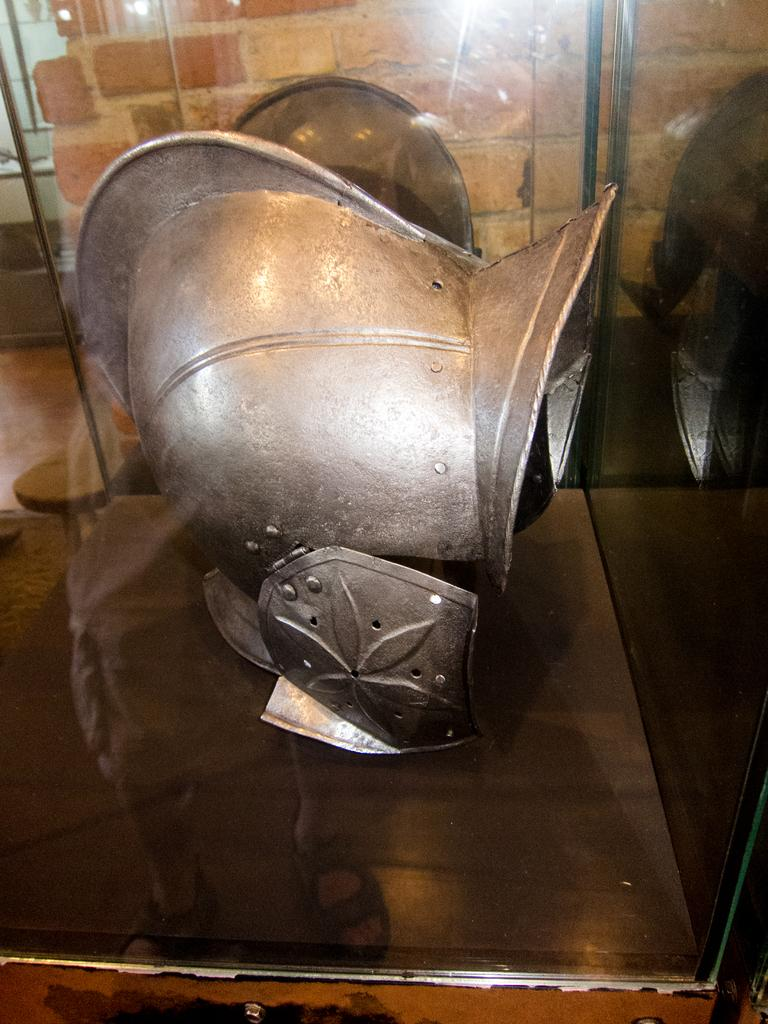What type of helmet is in the image? There is a war cavalry helmet in the image. How is the helmet displayed in the image? The helmet is inside a glass box. What can be seen in the background of the image? There is a wall in the background of the image. What type of juice is being served in the glass box with the helmet? There is no juice present in the image; the helmet is inside a glass box. What color are the trousers of the person wearing the helmet in the image? There is no person wearing the helmet in the image, as it is displayed inside a glass box. 